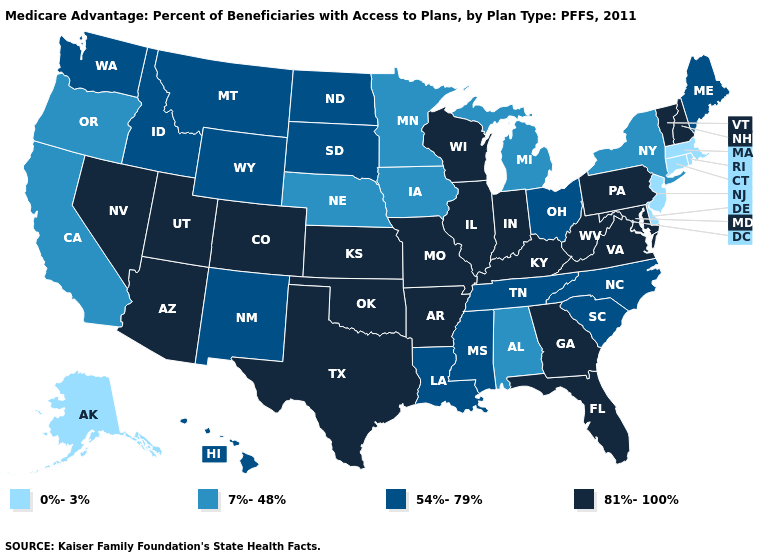Does Pennsylvania have the lowest value in the Northeast?
Quick response, please. No. What is the lowest value in states that border Utah?
Write a very short answer. 54%-79%. What is the value of Montana?
Be succinct. 54%-79%. Name the states that have a value in the range 7%-48%?
Write a very short answer. Alabama, California, Iowa, Michigan, Minnesota, Nebraska, New York, Oregon. What is the value of Utah?
Be succinct. 81%-100%. How many symbols are there in the legend?
Answer briefly. 4. Which states have the lowest value in the MidWest?
Be succinct. Iowa, Michigan, Minnesota, Nebraska. How many symbols are there in the legend?
Write a very short answer. 4. Name the states that have a value in the range 81%-100%?
Quick response, please. Arkansas, Arizona, Colorado, Florida, Georgia, Illinois, Indiana, Kansas, Kentucky, Maryland, Missouri, New Hampshire, Nevada, Oklahoma, Pennsylvania, Texas, Utah, Virginia, Vermont, Wisconsin, West Virginia. What is the lowest value in states that border Nebraska?
Give a very brief answer. 7%-48%. What is the value of Texas?
Short answer required. 81%-100%. Does Colorado have the highest value in the West?
Keep it brief. Yes. Does Wyoming have the same value as Idaho?
Give a very brief answer. Yes. What is the value of Illinois?
Quick response, please. 81%-100%. Does Colorado have the same value as Indiana?
Give a very brief answer. Yes. 